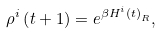<formula> <loc_0><loc_0><loc_500><loc_500>\rho ^ { i } \left ( t + 1 \right ) = e ^ { \beta H ^ { i } \left ( t \right ) _ { R } } ,</formula> 